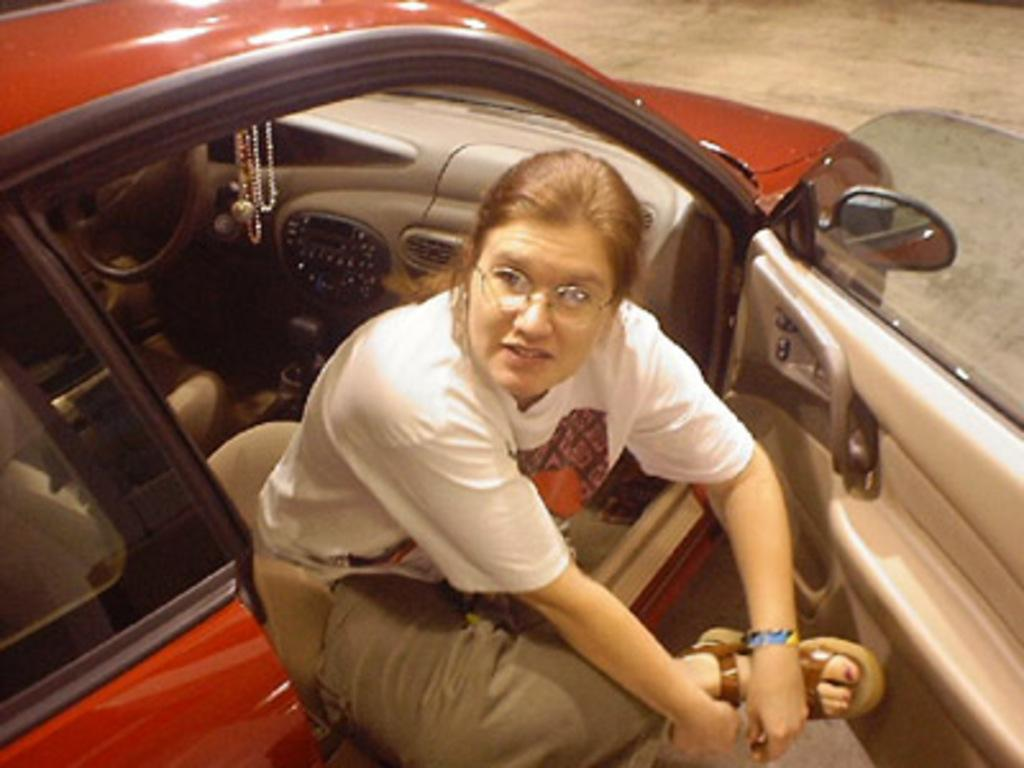Who is the main subject in the image? There is a woman in the image. What is the woman doing in the image? The woman is sitting on a car seat. What is the position of the car door in the image? The car door is open. What accessory is the woman wearing in the image? The woman is wearing spectacles. What type of pies is the woman eating in the image? There is no indication in the image that the woman is eating any pies, so it cannot be determined from the picture. 